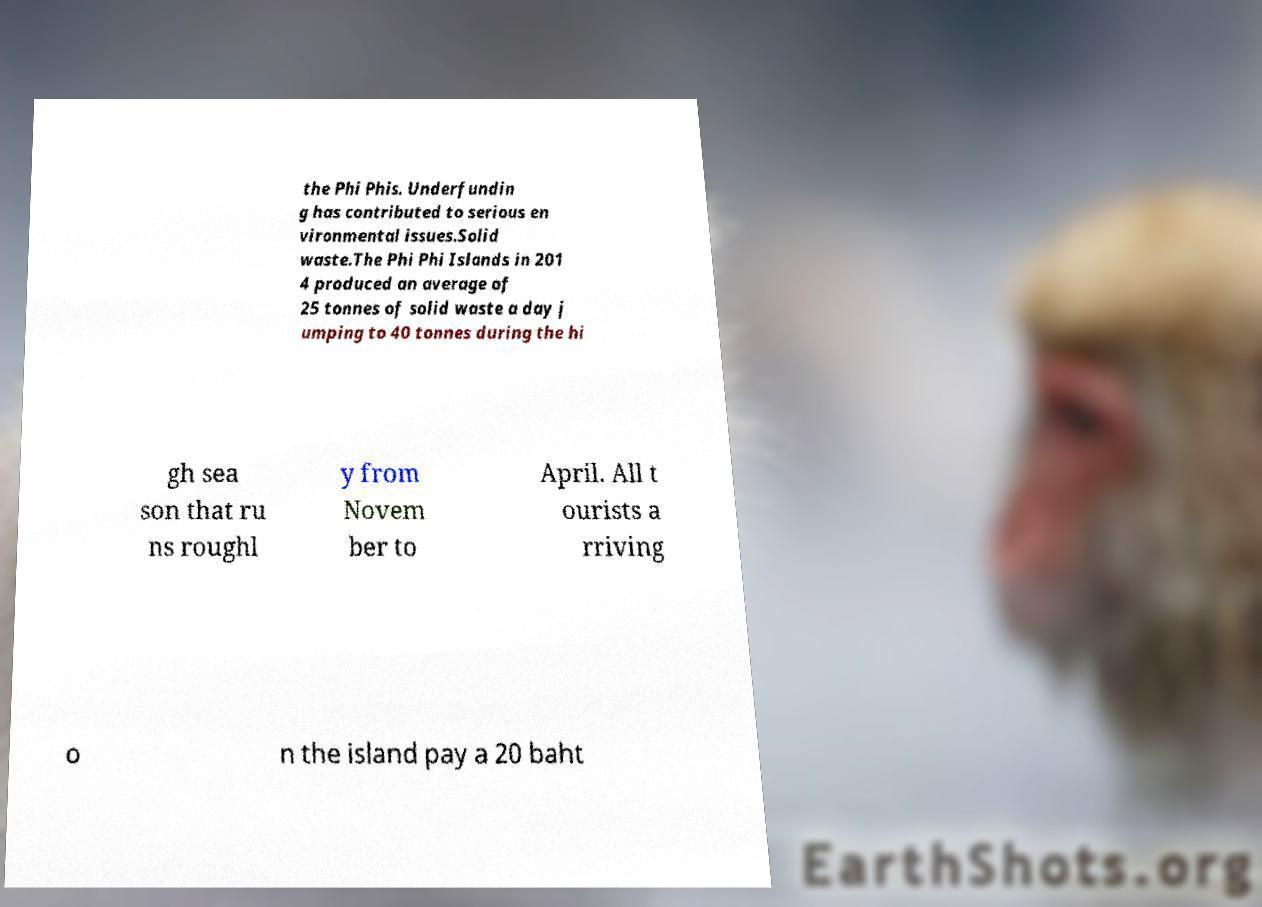There's text embedded in this image that I need extracted. Can you transcribe it verbatim? the Phi Phis. Underfundin g has contributed to serious en vironmental issues.Solid waste.The Phi Phi Islands in 201 4 produced an average of 25 tonnes of solid waste a day j umping to 40 tonnes during the hi gh sea son that ru ns roughl y from Novem ber to April. All t ourists a rriving o n the island pay a 20 baht 